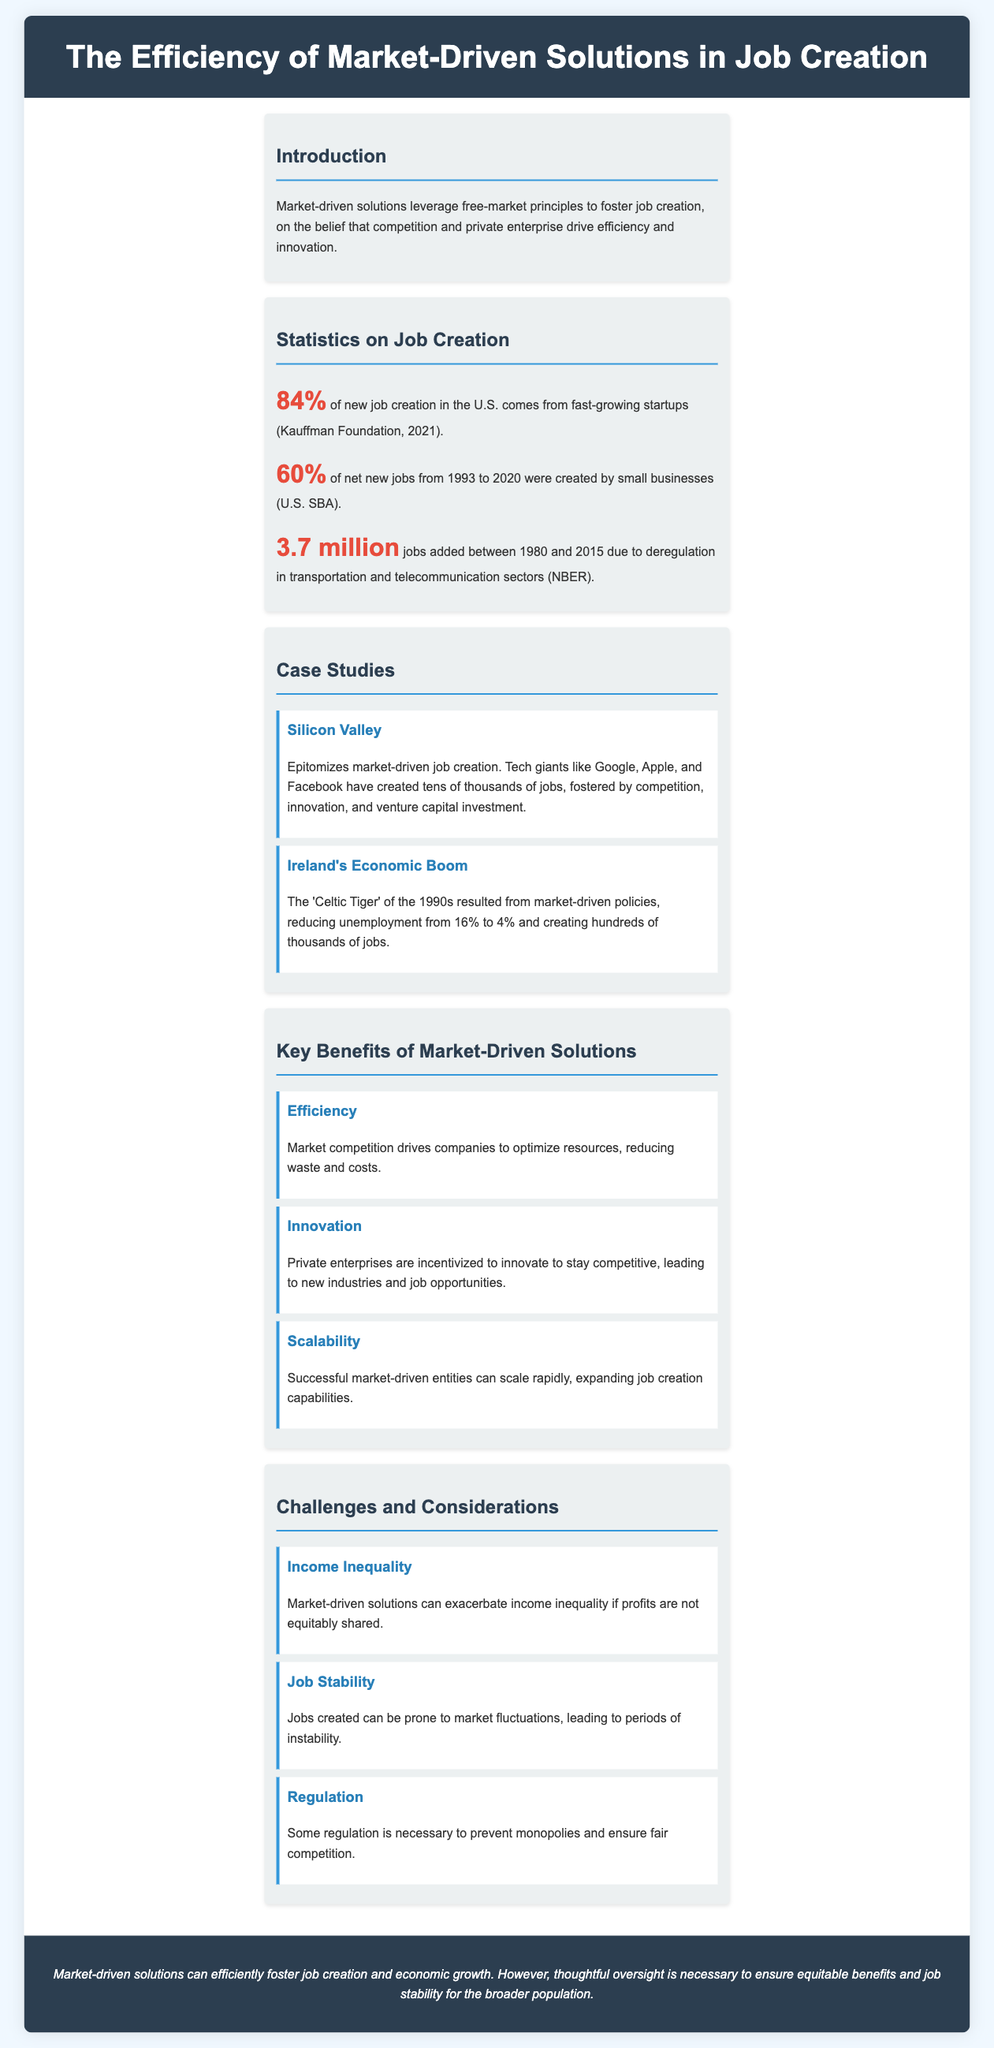What percentage of new job creation in the U.S. comes from fast-growing startups? The document states that 84% of new job creation in the U.S. comes from fast-growing startups according to the Kauffman Foundation, 2021.
Answer: 84% Which small business statistic is highlighted from the U.S. SBA? The document indicates that 60% of net new jobs from 1993 to 2020 were created by small businesses, citing the U.S. SBA.
Answer: 60% How many jobs were added due to deregulation according to the NBER? The document mentions that 3.7 million jobs were added between 1980 and 2015 due to deregulation in transportation and telecommunication sectors as per NBER.
Answer: 3.7 million What significant benefit is attributed to competition in market-driven solutions? The document highlights that efficiency is a key benefit, as market competition drives companies to optimize resources, reducing waste and costs.
Answer: Efficiency Which economic example reduced unemployment from 16% to 4%? The document refers to Ireland's Economic Boom, also known as the 'Celtic Tiger' of the 1990s, which reduced unemployment from 16% to 4%.
Answer: Ireland's Economic Boom What is one challenge associated with market-driven solutions mentioned in the document? The document states that income inequality is a challenge linked to market-driven solutions if profits are not equitably shared.
Answer: Income Inequality What color is used for the header background in the infographic? The document specifies that the header background color is #2c3e50.
Answer: #2c3e50 What industry showcased in a case study created tens of thousands of jobs through market competition? The document highlights Silicon Valley as an industry that created tens of thousands of jobs through competition and innovation.
Answer: Silicon Valley 